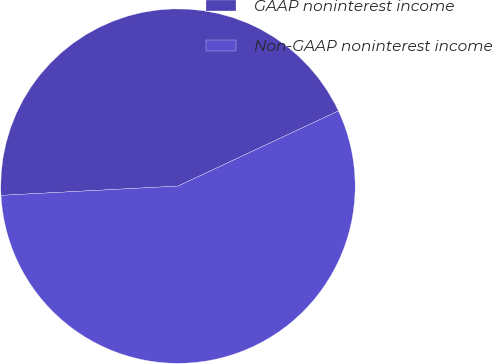Convert chart to OTSL. <chart><loc_0><loc_0><loc_500><loc_500><pie_chart><fcel>GAAP noninterest income<fcel>Non-GAAP noninterest income<nl><fcel>43.86%<fcel>56.14%<nl></chart> 